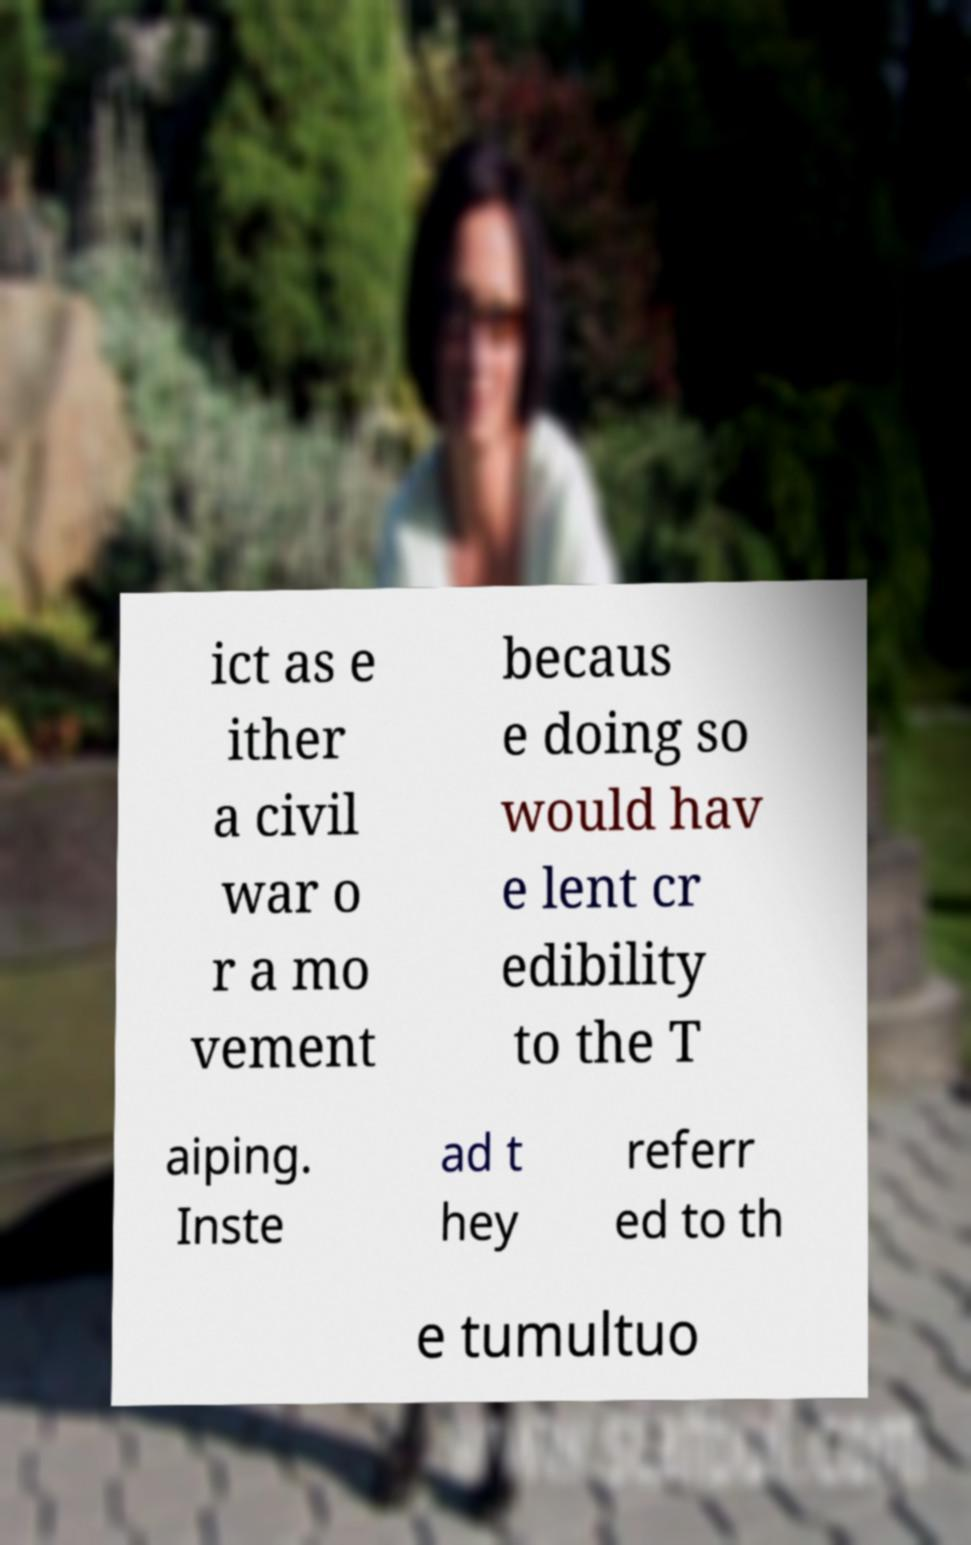Please read and relay the text visible in this image. What does it say? ict as e ither a civil war o r a mo vement becaus e doing so would hav e lent cr edibility to the T aiping. Inste ad t hey referr ed to th e tumultuo 